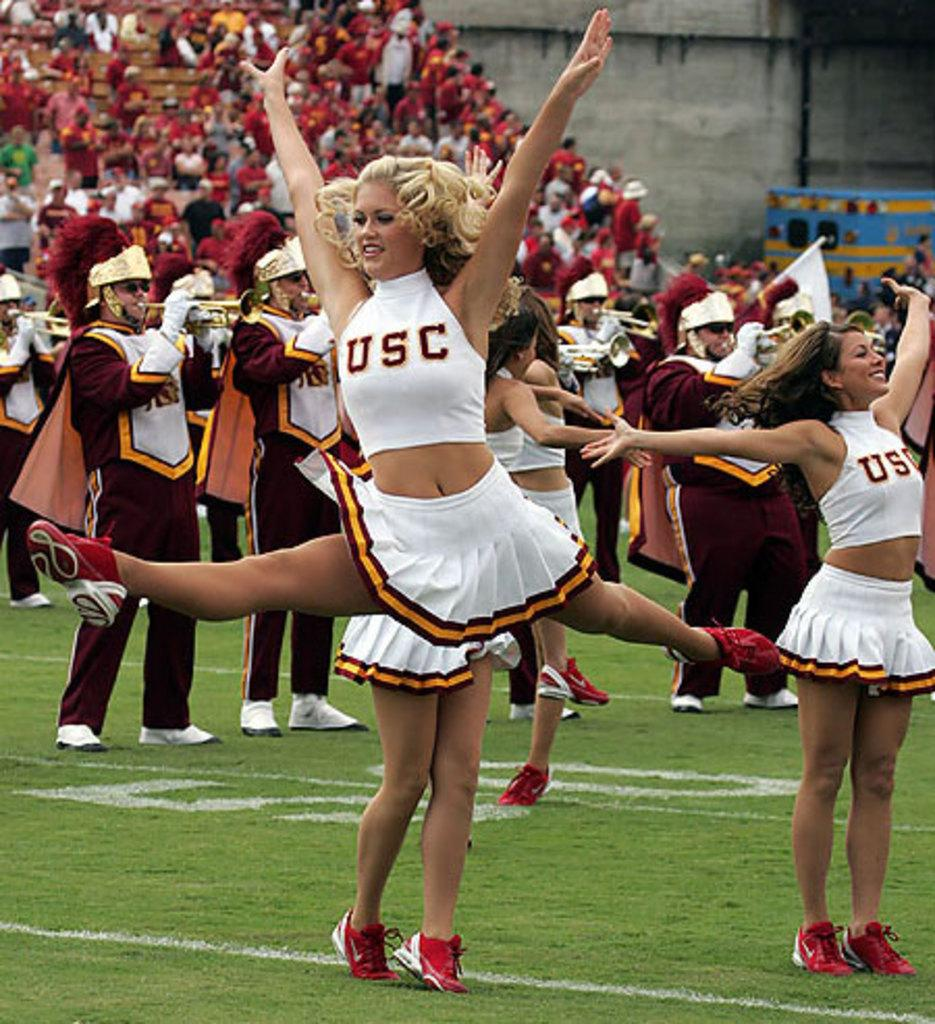<image>
Offer a succinct explanation of the picture presented. A USC cheerleader leaps in the air with her arms straight up. 